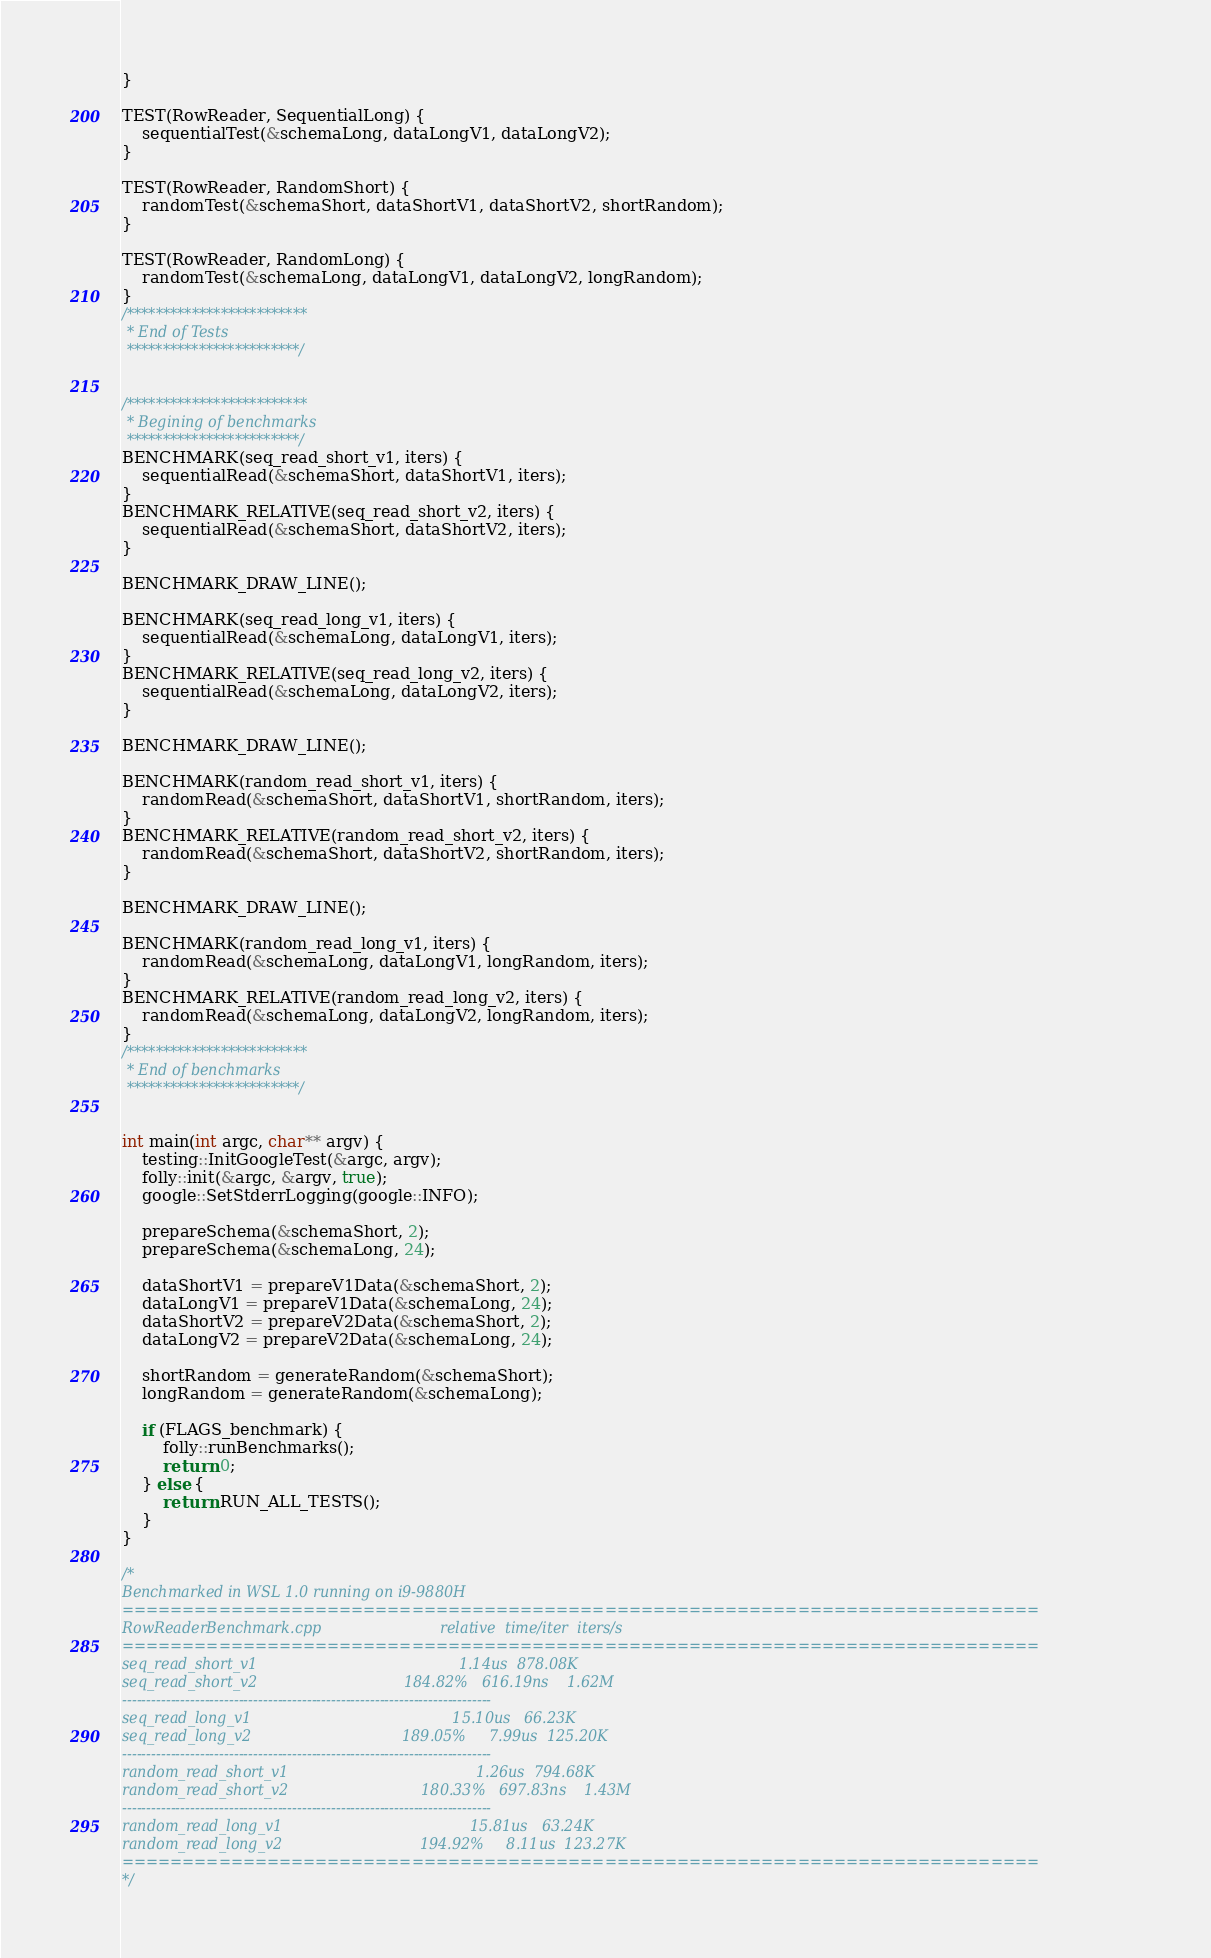<code> <loc_0><loc_0><loc_500><loc_500><_C++_>}

TEST(RowReader, SequentialLong) {
    sequentialTest(&schemaLong, dataLongV1, dataLongV2);
}

TEST(RowReader, RandomShort) {
    randomTest(&schemaShort, dataShortV1, dataShortV2, shortRandom);
}

TEST(RowReader, RandomLong) {
    randomTest(&schemaLong, dataLongV1, dataLongV2, longRandom);
}
/*************************
 * End of Tests
 ************************/


/*************************
 * Begining of benchmarks
 ************************/
BENCHMARK(seq_read_short_v1, iters) {
    sequentialRead(&schemaShort, dataShortV1, iters);
}
BENCHMARK_RELATIVE(seq_read_short_v2, iters) {
    sequentialRead(&schemaShort, dataShortV2, iters);
}

BENCHMARK_DRAW_LINE();

BENCHMARK(seq_read_long_v1, iters) {
    sequentialRead(&schemaLong, dataLongV1, iters);
}
BENCHMARK_RELATIVE(seq_read_long_v2, iters) {
    sequentialRead(&schemaLong, dataLongV2, iters);
}

BENCHMARK_DRAW_LINE();

BENCHMARK(random_read_short_v1, iters) {
    randomRead(&schemaShort, dataShortV1, shortRandom, iters);
}
BENCHMARK_RELATIVE(random_read_short_v2, iters) {
    randomRead(&schemaShort, dataShortV2, shortRandom, iters);
}

BENCHMARK_DRAW_LINE();

BENCHMARK(random_read_long_v1, iters) {
    randomRead(&schemaLong, dataLongV1, longRandom, iters);
}
BENCHMARK_RELATIVE(random_read_long_v2, iters) {
    randomRead(&schemaLong, dataLongV2, longRandom, iters);
}
/*************************
 * End of benchmarks
 ************************/


int main(int argc, char** argv) {
    testing::InitGoogleTest(&argc, argv);
    folly::init(&argc, &argv, true);
    google::SetStderrLogging(google::INFO);

    prepareSchema(&schemaShort, 2);
    prepareSchema(&schemaLong, 24);

    dataShortV1 = prepareV1Data(&schemaShort, 2);
    dataLongV1 = prepareV1Data(&schemaLong, 24);
    dataShortV2 = prepareV2Data(&schemaShort, 2);
    dataLongV2 = prepareV2Data(&schemaLong, 24);

    shortRandom = generateRandom(&schemaShort);
    longRandom = generateRandom(&schemaLong);

    if (FLAGS_benchmark) {
        folly::runBenchmarks();
        return 0;
    } else {
        return RUN_ALL_TESTS();
    }
}

/*
Benchmarked in WSL 1.0 running on i9-9880H
============================================================================
RowReaderBenchmark.cpp                          relative  time/iter  iters/s
============================================================================
seq_read_short_v1                                            1.14us  878.08K
seq_read_short_v2                                184.82%   616.19ns    1.62M
----------------------------------------------------------------------------
seq_read_long_v1                                            15.10us   66.23K
seq_read_long_v2                                 189.05%     7.99us  125.20K
----------------------------------------------------------------------------
random_read_short_v1                                         1.26us  794.68K
random_read_short_v2                             180.33%   697.83ns    1.43M
----------------------------------------------------------------------------
random_read_long_v1                                         15.81us   63.24K
random_read_long_v2                              194.92%     8.11us  123.27K
============================================================================
*/

</code> 